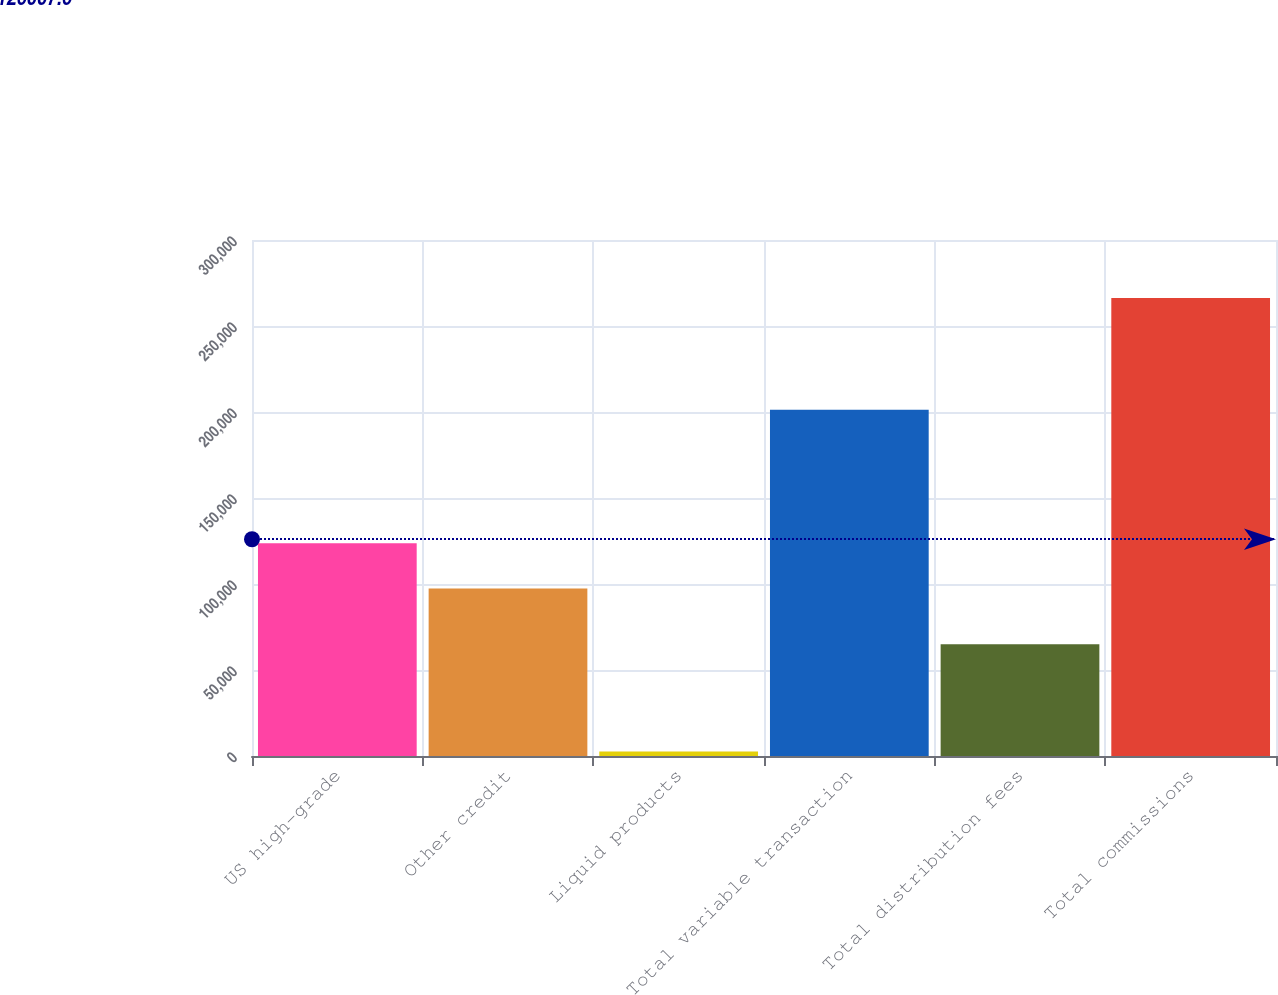<chart> <loc_0><loc_0><loc_500><loc_500><bar_chart><fcel>US high-grade<fcel>Other credit<fcel>Liquid products<fcel>Total variable transaction<fcel>Total distribution fees<fcel>Total commissions<nl><fcel>123686<fcel>97323<fcel>2595<fcel>201266<fcel>64955<fcel>266221<nl></chart> 